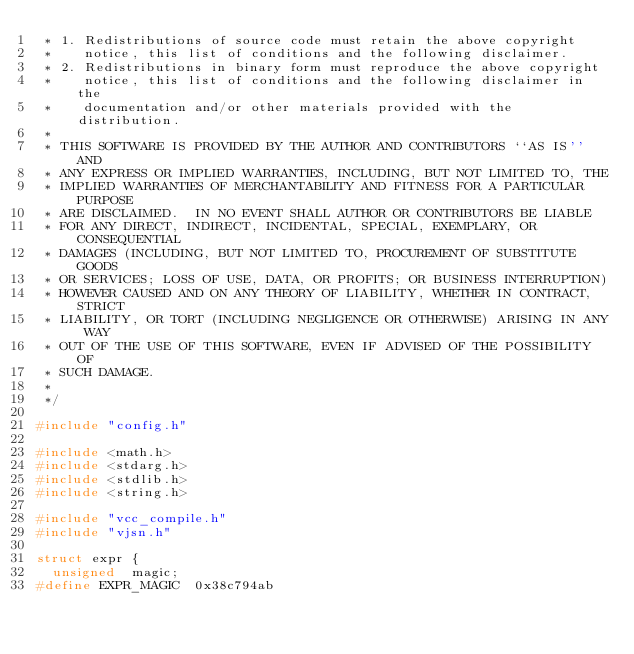<code> <loc_0><loc_0><loc_500><loc_500><_C_> * 1. Redistributions of source code must retain the above copyright
 *    notice, this list of conditions and the following disclaimer.
 * 2. Redistributions in binary form must reproduce the above copyright
 *    notice, this list of conditions and the following disclaimer in the
 *    documentation and/or other materials provided with the distribution.
 *
 * THIS SOFTWARE IS PROVIDED BY THE AUTHOR AND CONTRIBUTORS ``AS IS'' AND
 * ANY EXPRESS OR IMPLIED WARRANTIES, INCLUDING, BUT NOT LIMITED TO, THE
 * IMPLIED WARRANTIES OF MERCHANTABILITY AND FITNESS FOR A PARTICULAR PURPOSE
 * ARE DISCLAIMED.  IN NO EVENT SHALL AUTHOR OR CONTRIBUTORS BE LIABLE
 * FOR ANY DIRECT, INDIRECT, INCIDENTAL, SPECIAL, EXEMPLARY, OR CONSEQUENTIAL
 * DAMAGES (INCLUDING, BUT NOT LIMITED TO, PROCUREMENT OF SUBSTITUTE GOODS
 * OR SERVICES; LOSS OF USE, DATA, OR PROFITS; OR BUSINESS INTERRUPTION)
 * HOWEVER CAUSED AND ON ANY THEORY OF LIABILITY, WHETHER IN CONTRACT, STRICT
 * LIABILITY, OR TORT (INCLUDING NEGLIGENCE OR OTHERWISE) ARISING IN ANY WAY
 * OUT OF THE USE OF THIS SOFTWARE, EVEN IF ADVISED OF THE POSSIBILITY OF
 * SUCH DAMAGE.
 *
 */

#include "config.h"

#include <math.h>
#include <stdarg.h>
#include <stdlib.h>
#include <string.h>

#include "vcc_compile.h"
#include "vjsn.h"

struct expr {
	unsigned	magic;
#define EXPR_MAGIC	0x38c794ab</code> 